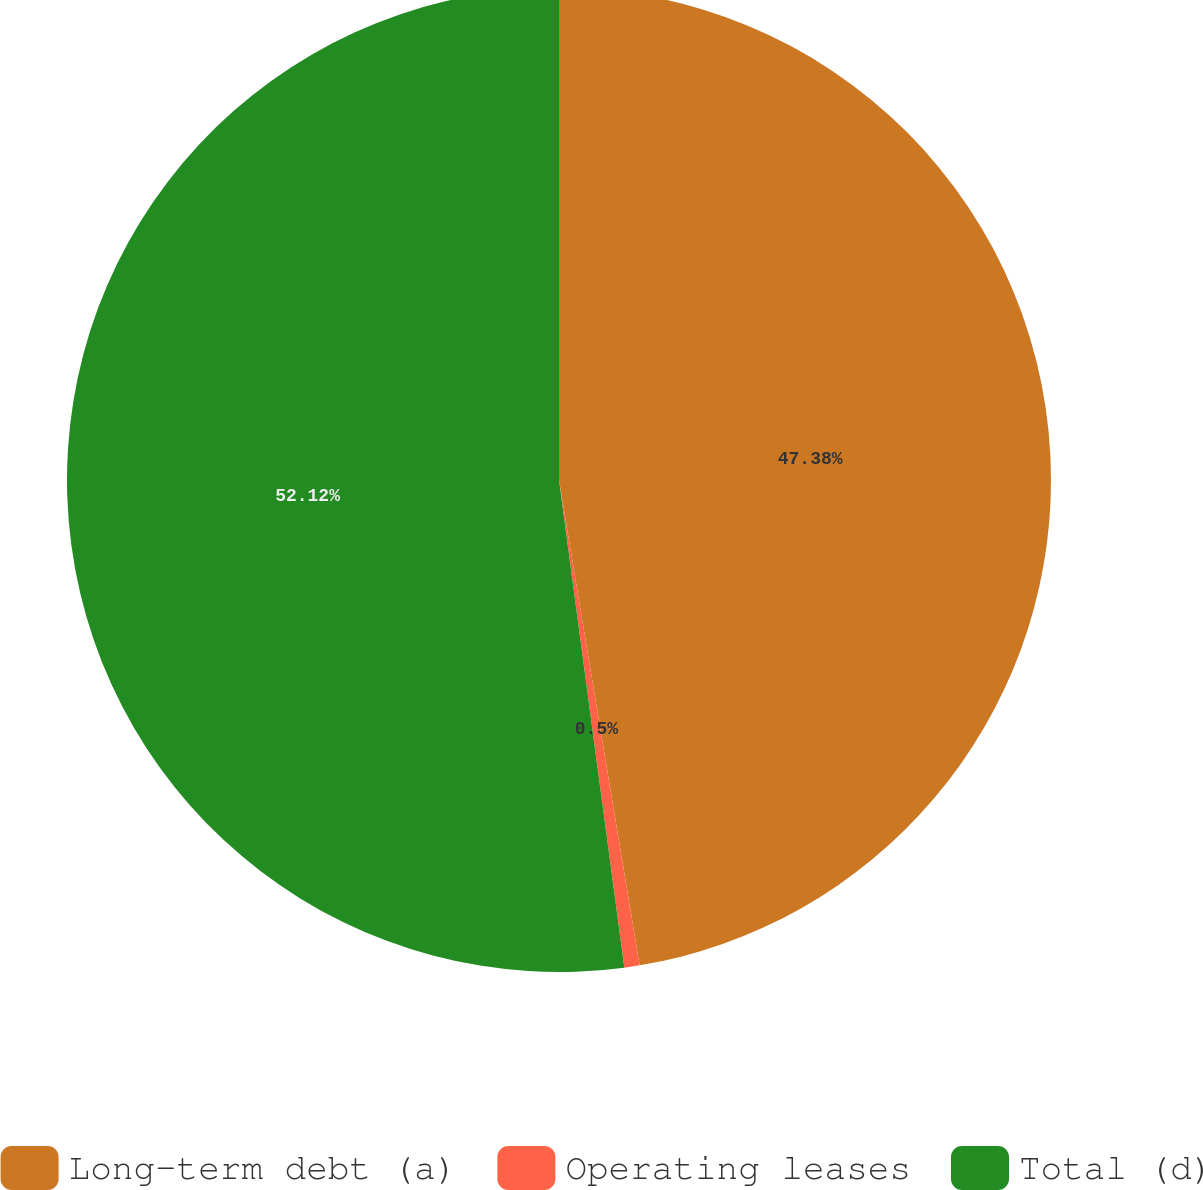<chart> <loc_0><loc_0><loc_500><loc_500><pie_chart><fcel>Long-term debt (a)<fcel>Operating leases<fcel>Total (d)<nl><fcel>47.38%<fcel>0.5%<fcel>52.12%<nl></chart> 